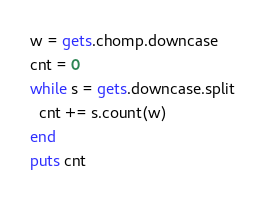Convert code to text. <code><loc_0><loc_0><loc_500><loc_500><_Ruby_>w = gets.chomp.downcase
cnt = 0
while s = gets.downcase.split
  cnt += s.count(w)
end
puts cnt
</code> 